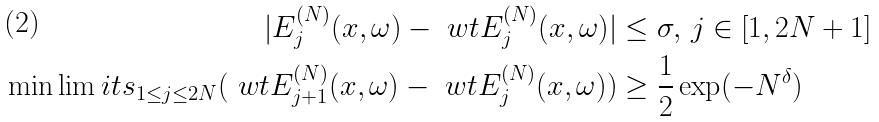Convert formula to latex. <formula><loc_0><loc_0><loc_500><loc_500>| E _ { j } ^ { ( N ) } ( x , \omega ) - \ w t { E } _ { j } ^ { ( N ) } ( x , \omega ) | & \leq \sigma , \, j \in [ 1 , 2 N + 1 ] \\ \min \lim i t s _ { 1 \leq j \leq 2 N } ( \ w t { E } _ { j + 1 } ^ { ( N ) } ( x , \omega ) - \ w t { E } _ { j } ^ { ( N ) } ( x , \omega ) ) & \geq \frac { 1 } { 2 } \exp ( - N ^ { \delta } )</formula> 